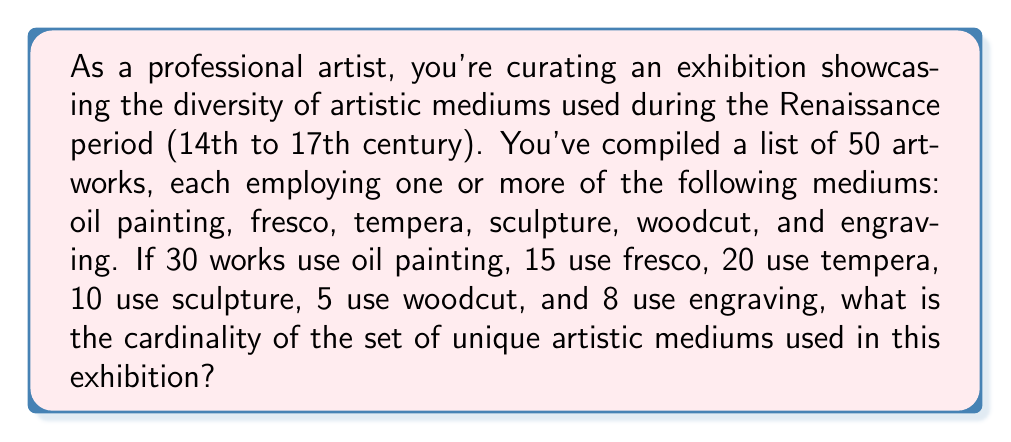Help me with this question. To solve this problem, we need to understand that the cardinality of a set is the number of unique elements in that set. In this case, we're looking for the number of unique artistic mediums used across all the artworks.

Let's approach this step-by-step:

1. First, let's list out all the mediums mentioned:
   - Oil painting
   - Fresco
   - Tempera
   - Sculpture
   - Woodcut
   - Engraving

2. Now, we need to determine if all of these mediums are actually used in the exhibition. We can see that each medium has a non-zero number of artworks associated with it:
   - Oil painting: 30 works
   - Fresco: 15 works
   - Tempera: 20 works
   - Sculpture: 10 works
   - Woodcut: 5 works
   - Engraving: 8 works

3. Since all mediums are represented, the cardinality of the set of unique artistic mediums is equal to the number of mediums listed.

4. We can express this mathematically as:

   Let $A$ be the set of unique artistic mediums used in the exhibition.
   
   $A = \{\text{oil painting, fresco, tempera, sculpture, woodcut, engraving}\}$

   The cardinality of set $A$ is denoted as $|A|$.

5. To find $|A|$, we simply count the number of elements in the set, which is 6.

Therefore, the cardinality of the set of unique artistic mediums used in this Renaissance exhibition is 6.
Answer: $|A| = 6$ 